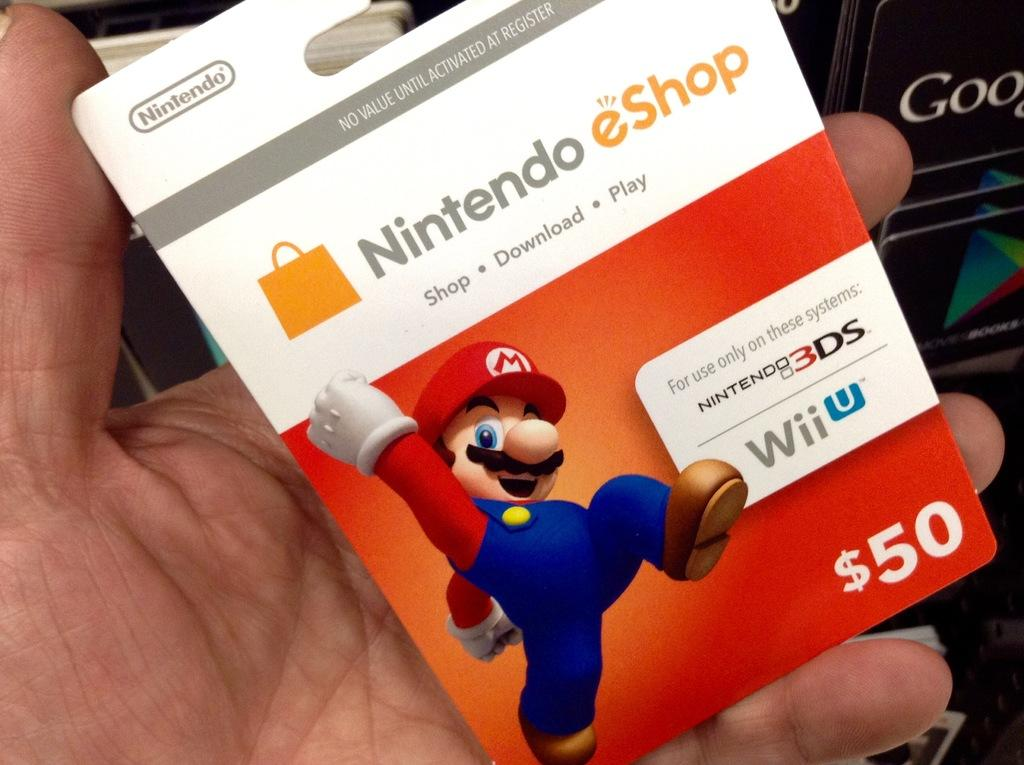What is being held by the hand in the image? The hand is holding a card. What is depicted on the card? The card contains an image of a cartoon. Is there any text on the card? Yes, there is text written on the card. What type of list can be seen hanging from the rod in the image? There is no list or rod present in the image; it only features a hand holding a card with a cartoon image and text. 